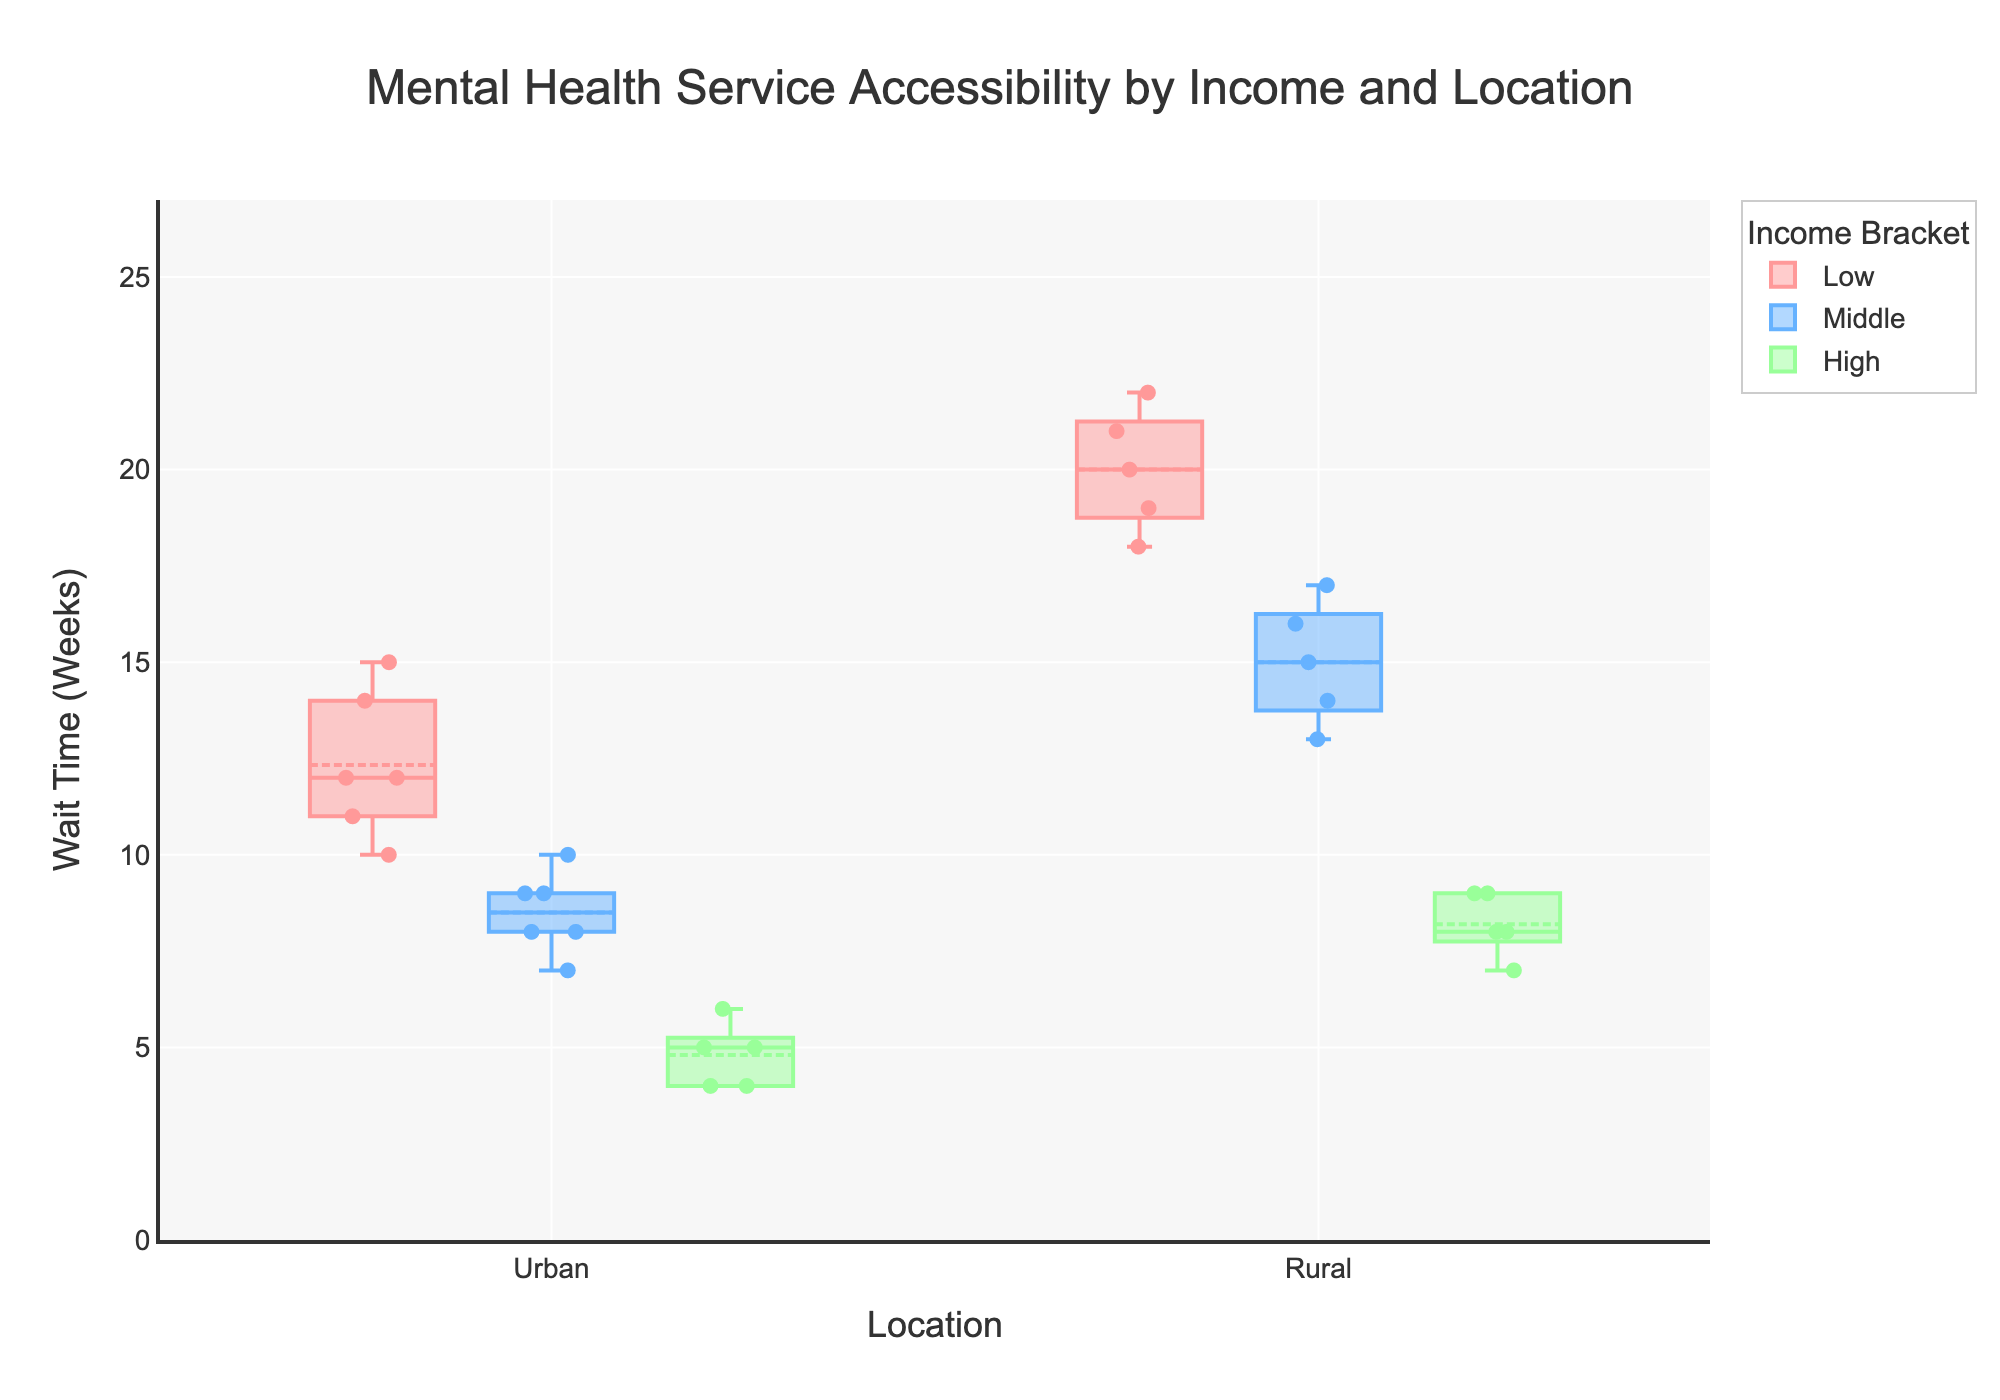What is the title of the figure? The title is usually at the top of the figure. Here, it is placed centrally at the very top.
Answer: Mental Health Service Accessibility by Income and Location How many income brackets are there in the figure? The figure shows different colors representing distinct income brackets. There are three colors indicating three income brackets.
Answer: Three Which location has the highest median wait time for the low-income bracket? By looking at the middle line of the boxes in the box plot, we can find the median wait time for each group. For the low-income bracket, the median is higher in the Rural group.
Answer: Rural What is the shortest wait time shown for the high-income bracket in urban locations? The scatter points on the box plot indicate individual data points. The shortest wait time point for high-income in Urban locations is at 4 weeks.
Answer: 4 weeks Which income bracket experiences the worst access to mental health services in rural areas? The color and label for "Very Poor" access can be seen in the section of the box plot referring to Rural locations. The Low-income bracket has the majority of "Very Poor" access points.
Answer: Low What is the range of wait times (difference between the maximum and minimum wait times) for the middle-income bracket in rural locations? The highest wait time for Middle-income in Rural areas is 17 weeks, and the lowest wait time is 13 weeks. So, the range is the difference between these values. 17 - 13 = 4 weeks.
Answer: 4 weeks Compare the median wait time for high-income brackets in urban and rural locations. Which is higher? By looking at the line that represents the median within the boxes for the high-income group, the Urban median is lower than the Rural median. This can be seen as the box for Urban is closer to the lower axis.
Answer: Rural On average, do low-income individuals face longer wait times compared to middle-income individuals in urban areas? The median values for the low-income bracket are around 12 weeks, while for middle-income, they are around 8 weeks in urban areas. Since 12 is greater than 8, low-income individuals face longer wait times on average.
Answer: Yes 